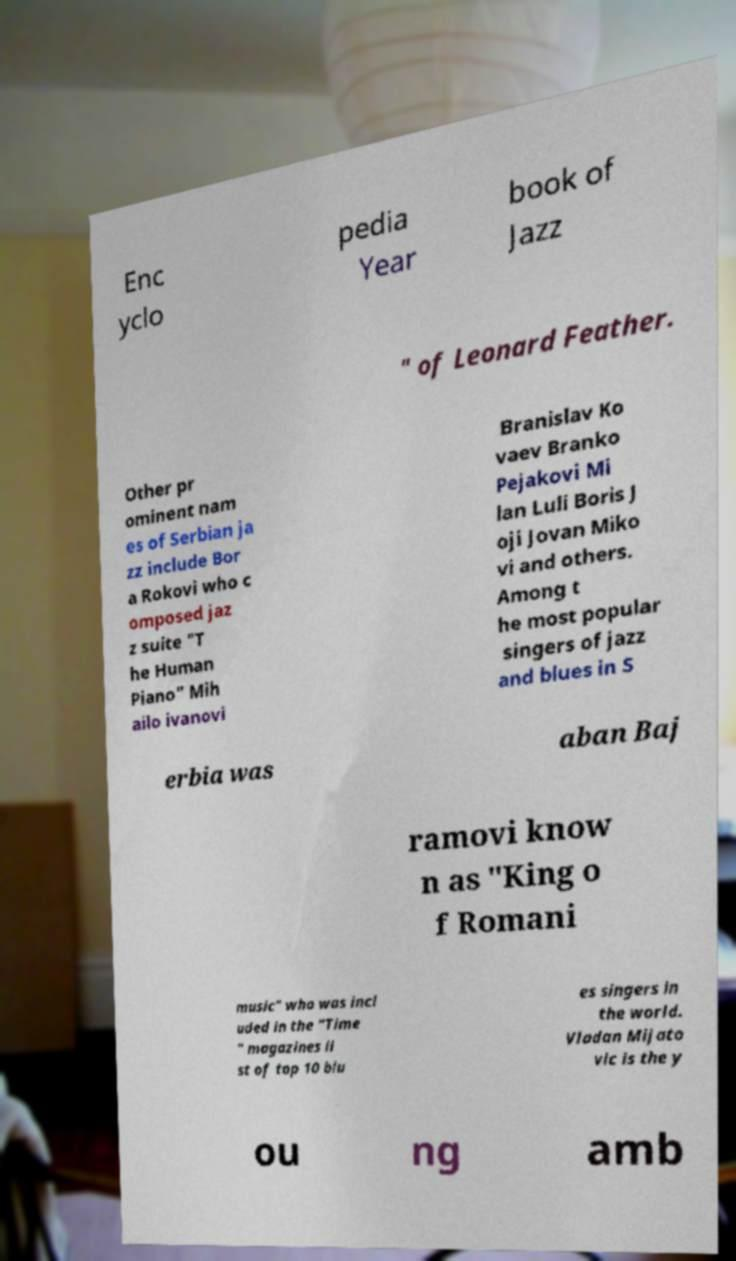What messages or text are displayed in this image? I need them in a readable, typed format. Enc yclo pedia Year book of Jazz " of Leonard Feather. Other pr ominent nam es of Serbian ja zz include Bor a Rokovi who c omposed jaz z suite "T he Human Piano" Mih ailo ivanovi Branislav Ko vaev Branko Pejakovi Mi lan Luli Boris J oji Jovan Miko vi and others. Among t he most popular singers of jazz and blues in S erbia was aban Baj ramovi know n as "King o f Romani music" who was incl uded in the "Time " magazines li st of top 10 blu es singers in the world. Vladan Mijato vic is the y ou ng amb 